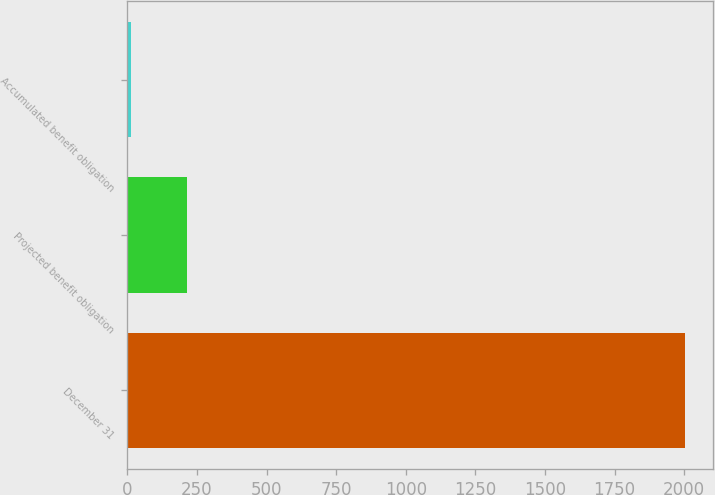Convert chart to OTSL. <chart><loc_0><loc_0><loc_500><loc_500><bar_chart><fcel>December 31<fcel>Projected benefit obligation<fcel>Accumulated benefit obligation<nl><fcel>2003<fcel>213.44<fcel>14.6<nl></chart> 